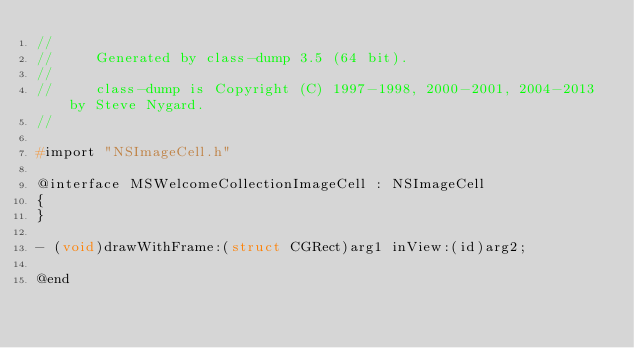<code> <loc_0><loc_0><loc_500><loc_500><_C_>//
//     Generated by class-dump 3.5 (64 bit).
//
//     class-dump is Copyright (C) 1997-1998, 2000-2001, 2004-2013 by Steve Nygard.
//

#import "NSImageCell.h"

@interface MSWelcomeCollectionImageCell : NSImageCell
{
}

- (void)drawWithFrame:(struct CGRect)arg1 inView:(id)arg2;

@end

</code> 